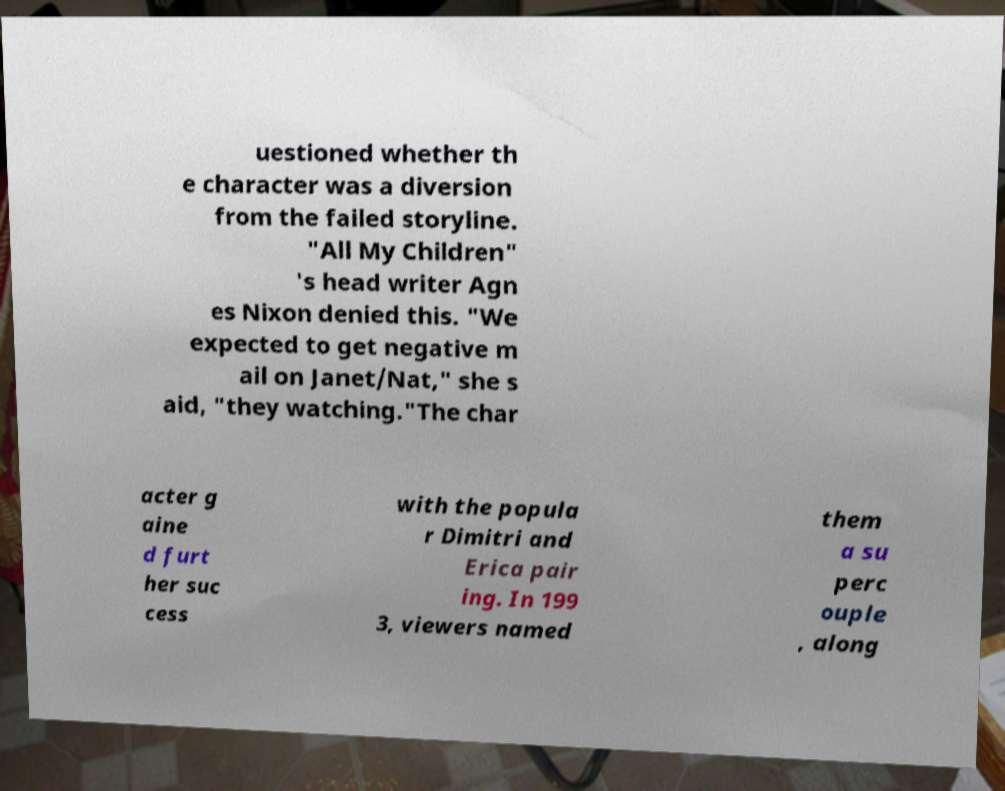Please identify and transcribe the text found in this image. uestioned whether th e character was a diversion from the failed storyline. "All My Children" 's head writer Agn es Nixon denied this. "We expected to get negative m ail on Janet/Nat," she s aid, "they watching."The char acter g aine d furt her suc cess with the popula r Dimitri and Erica pair ing. In 199 3, viewers named them a su perc ouple , along 